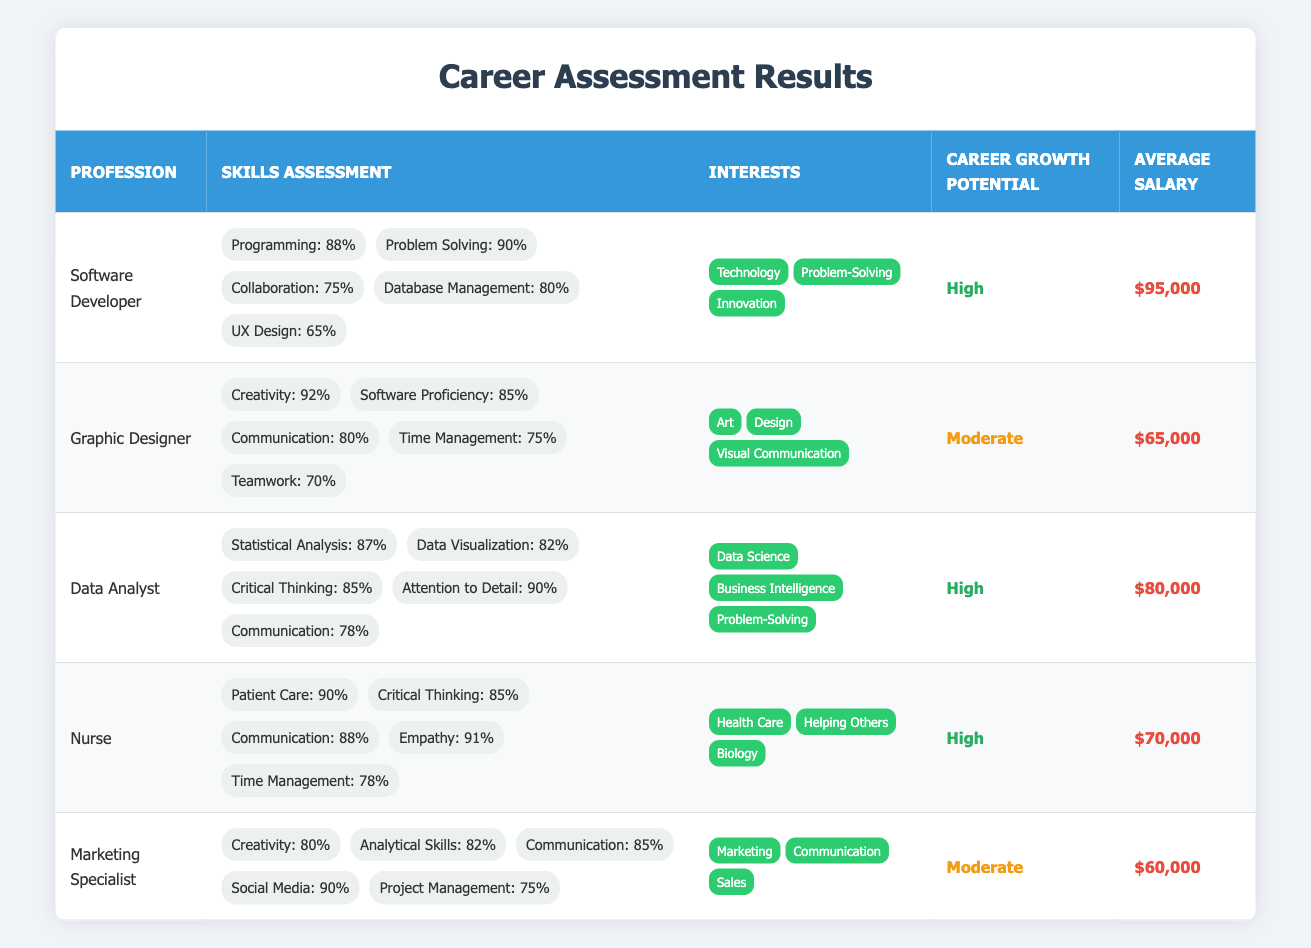What is the average salary for a Software Developer? The average salary for a Software Developer is listed in the table as $95,000.
Answer: $95,000 Which profession has the highest skill level in creativity? By comparing the skills assessment for all professions listed in the table, Graphic Designer has the highest creativity score of 92%.
Answer: Graphic Designer Is the career growth potential for Data Analyst high? The table indicates that the career growth potential for Data Analyst is categorized as "High."
Answer: Yes What is the average salary for professions with high career growth potential? The average salaries for professions with high career growth potential are: Software Developer ($95,000), Data Analyst ($80,000), and Nurse ($70,000). To find the average, we sum these values: $95,000 + $80,000 + $70,000 = $245,000. Dividing by the number of professions (3), we get $245,000 / 3 = $81,666.67.
Answer: $81,667 Which profession has the lowest score in collaboration skills? Looking at the skills assessment for collaboration, Software Developer has a score of 75%, which is the lowest among the listed professions.
Answer: Software Developer Does the Marketing Specialist have more analytical skills than the Graphic Designer? By comparing the skills assessment values for both professions, we see that Marketing Specialist has an analytical skills score of 82%, while Graphic Designer does not have a specific score for analytical skills mentioned in the table. Therefore, we cannot confirm that Marketing Specialist has more analytical skills.
Answer: No What is the total score for problem-solving skills among the listed professions? The problem-solving skills scores appear for Software Developer (90%), Data Analyst (85%), and Marketing Specialist (not measured). So, we only consider the first two: 90 + 85 = 175.
Answer: 175 